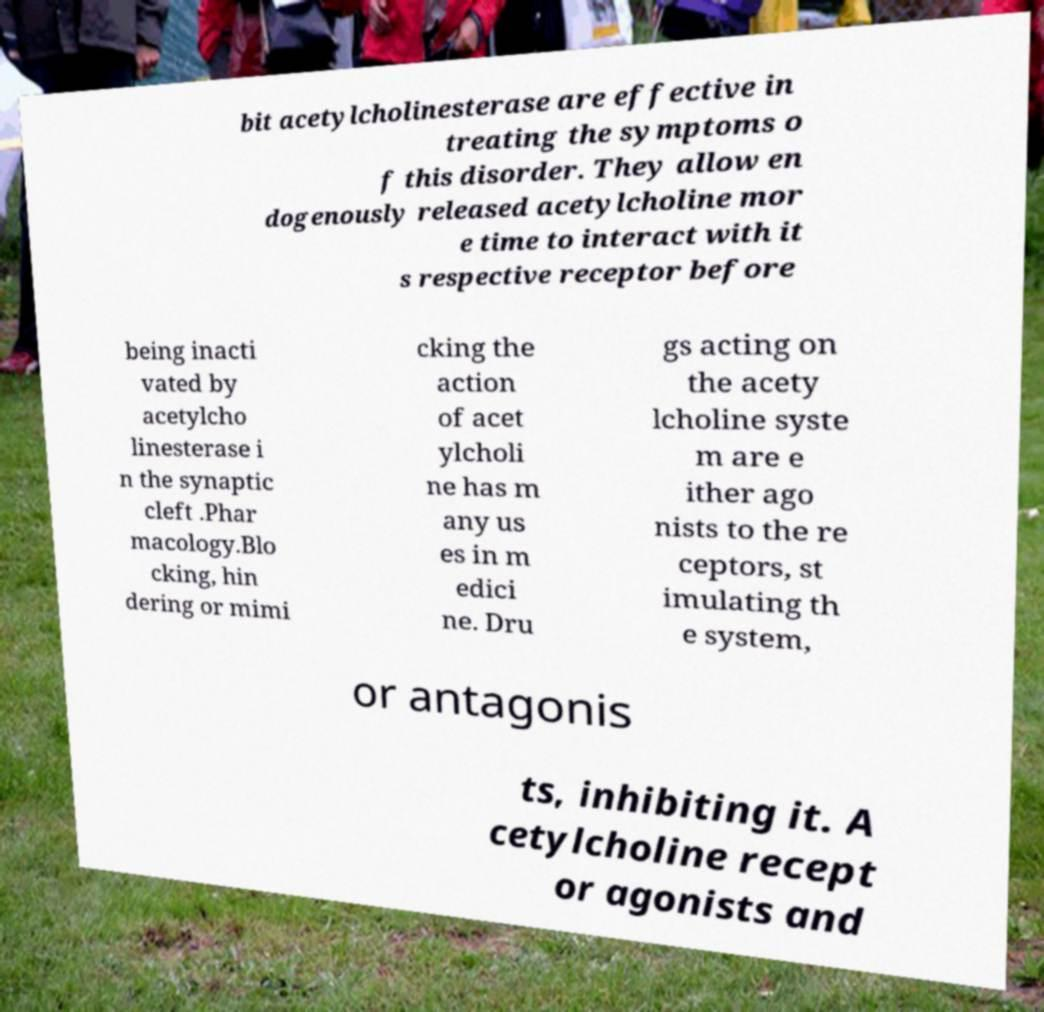Please identify and transcribe the text found in this image. bit acetylcholinesterase are effective in treating the symptoms o f this disorder. They allow en dogenously released acetylcholine mor e time to interact with it s respective receptor before being inacti vated by acetylcho linesterase i n the synaptic cleft .Phar macology.Blo cking, hin dering or mimi cking the action of acet ylcholi ne has m any us es in m edici ne. Dru gs acting on the acety lcholine syste m are e ither ago nists to the re ceptors, st imulating th e system, or antagonis ts, inhibiting it. A cetylcholine recept or agonists and 